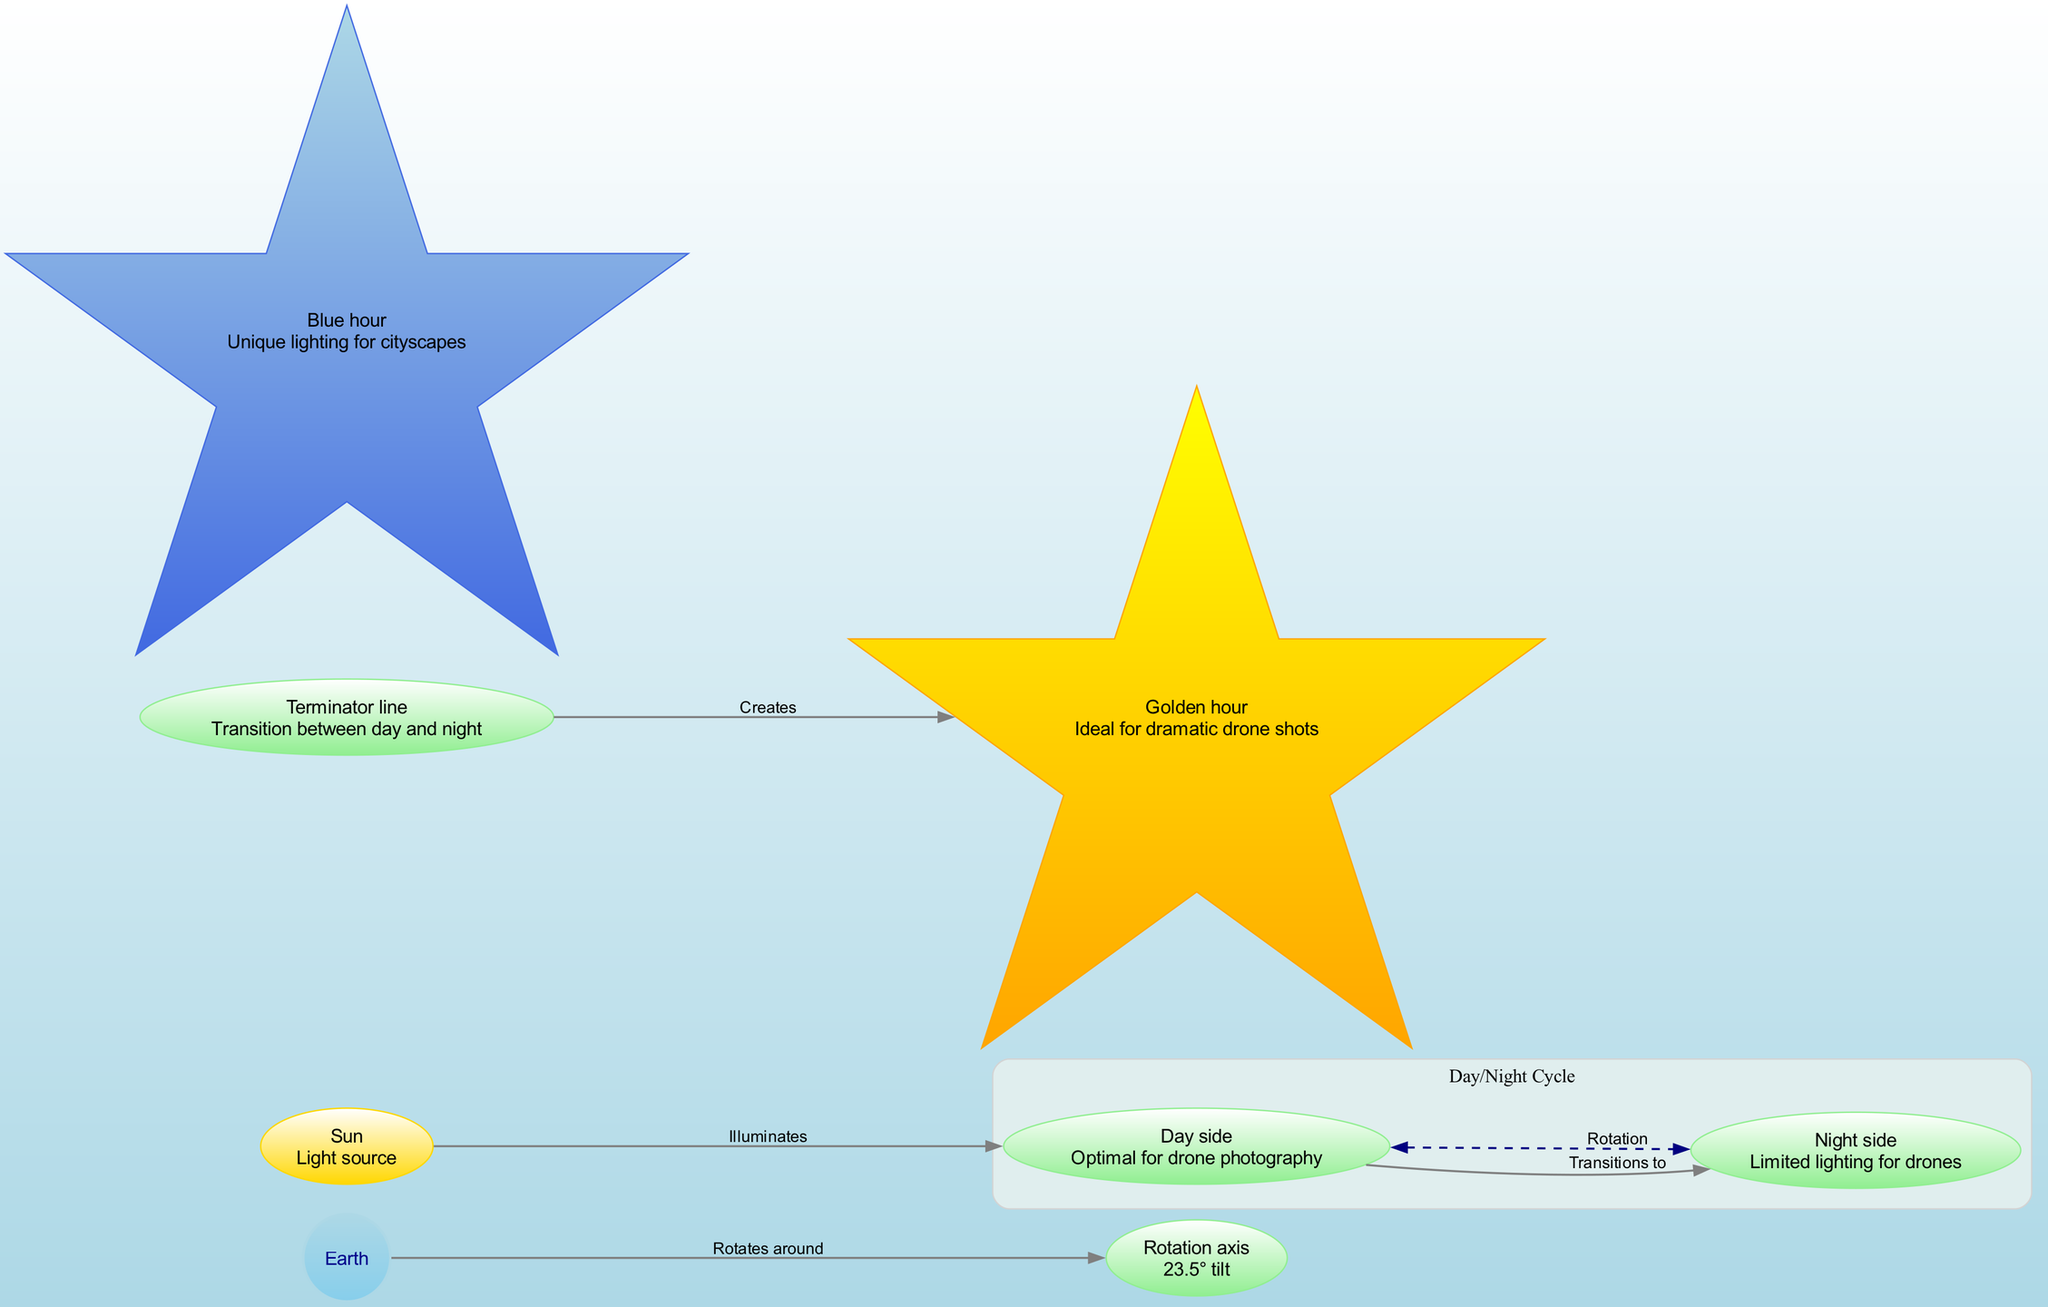What is the central object in this diagram? The diagram depicts Earth as the central object, being the main focus of the illustration.
Answer: Earth Which element is described as the light source? The diagram clearly labels the Sun as the light source, illuminating the Earth.
Answer: Sun What tilt does the rotation axis have? The diagram indicates a tilt of 23.5° for the rotation axis, highlighting its significance in the Earth's rotation.
Answer: 23.5° How many distinct elements are represented in the diagram? Counting all named elements based on the provided data, there are a total of seven distinct elements.
Answer: 7 What is the term for the line that transitions between day and night? The diagram identifies this line as the Terminator line, marking the boundary between illuminated and dark areas.
Answer: Terminator line Which hour is depicted as ideal for dramatic drone shots? According to the diagram, the Golden hour is highlighted as the optimal time for capturing dramatic photography with drones.
Answer: Golden hour What effect does the Sun have on the Day side? As illustrated in the diagram, the Sun illuminates the Day side, directly impacting lighting conditions for photography.
Answer: Illuminates How does the Day side relate to the Night side? The diagram shows that the Day side transitions to the Night side, indicating a flow from one condition to the other as Earth rotates.
Answer: Transitions to What two times are emphasized for unique lighting effects? The diagram highlights two specific times, the Golden hour and Blue hour, noted for their unique lighting suitable for different photography styles.
Answer: Golden hour and Blue hour What creates the Golden hour in the diagram? The illustration indicates that the Terminator line creates the Golden hour as it progresses, affecting the lighting conditions throughout the transition.
Answer: Creates 